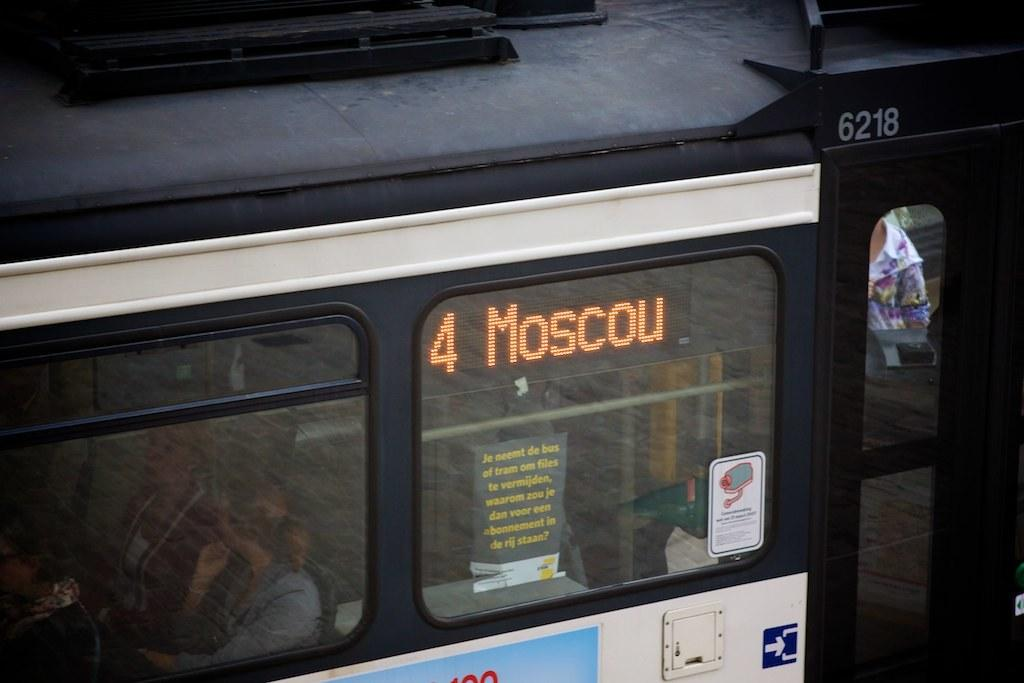<image>
Relay a brief, clear account of the picture shown. The number four bus is travelling to Moscou. 